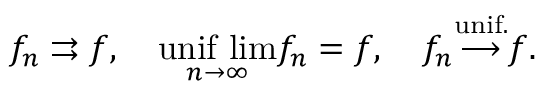<formula> <loc_0><loc_0><loc_500><loc_500>f _ { n } \right r i g h t a r r o w s f , \quad \underset { n \to \infty } { u n i f \ l i m } f _ { n } = f , \quad f _ { n } { \overset { u n i f . } { \longrightarrow } } f .</formula> 